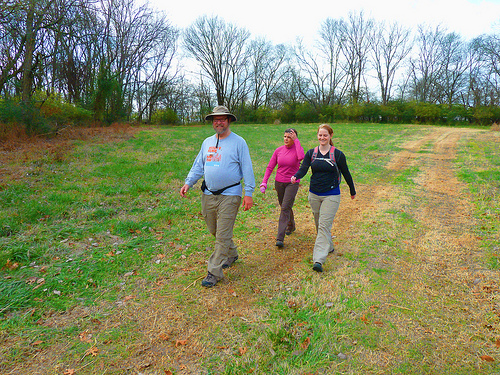<image>
Is the man in front of the woman? Yes. The man is positioned in front of the woman, appearing closer to the camera viewpoint. Is the belt above the shoe? Yes. The belt is positioned above the shoe in the vertical space, higher up in the scene. 